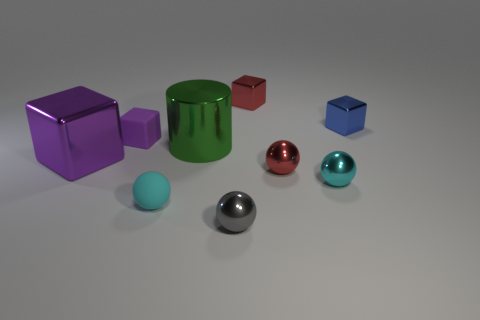Subtract all red balls. How many balls are left? 3 Subtract all tiny red blocks. How many blocks are left? 3 Subtract all spheres. How many objects are left? 5 Subtract 1 spheres. How many spheres are left? 3 Add 1 small metal things. How many objects exist? 10 Subtract all gray balls. How many red cubes are left? 1 Subtract all blue objects. Subtract all big purple cubes. How many objects are left? 7 Add 2 small red objects. How many small red objects are left? 4 Add 8 large brown metallic spheres. How many large brown metallic spheres exist? 8 Subtract 0 brown spheres. How many objects are left? 9 